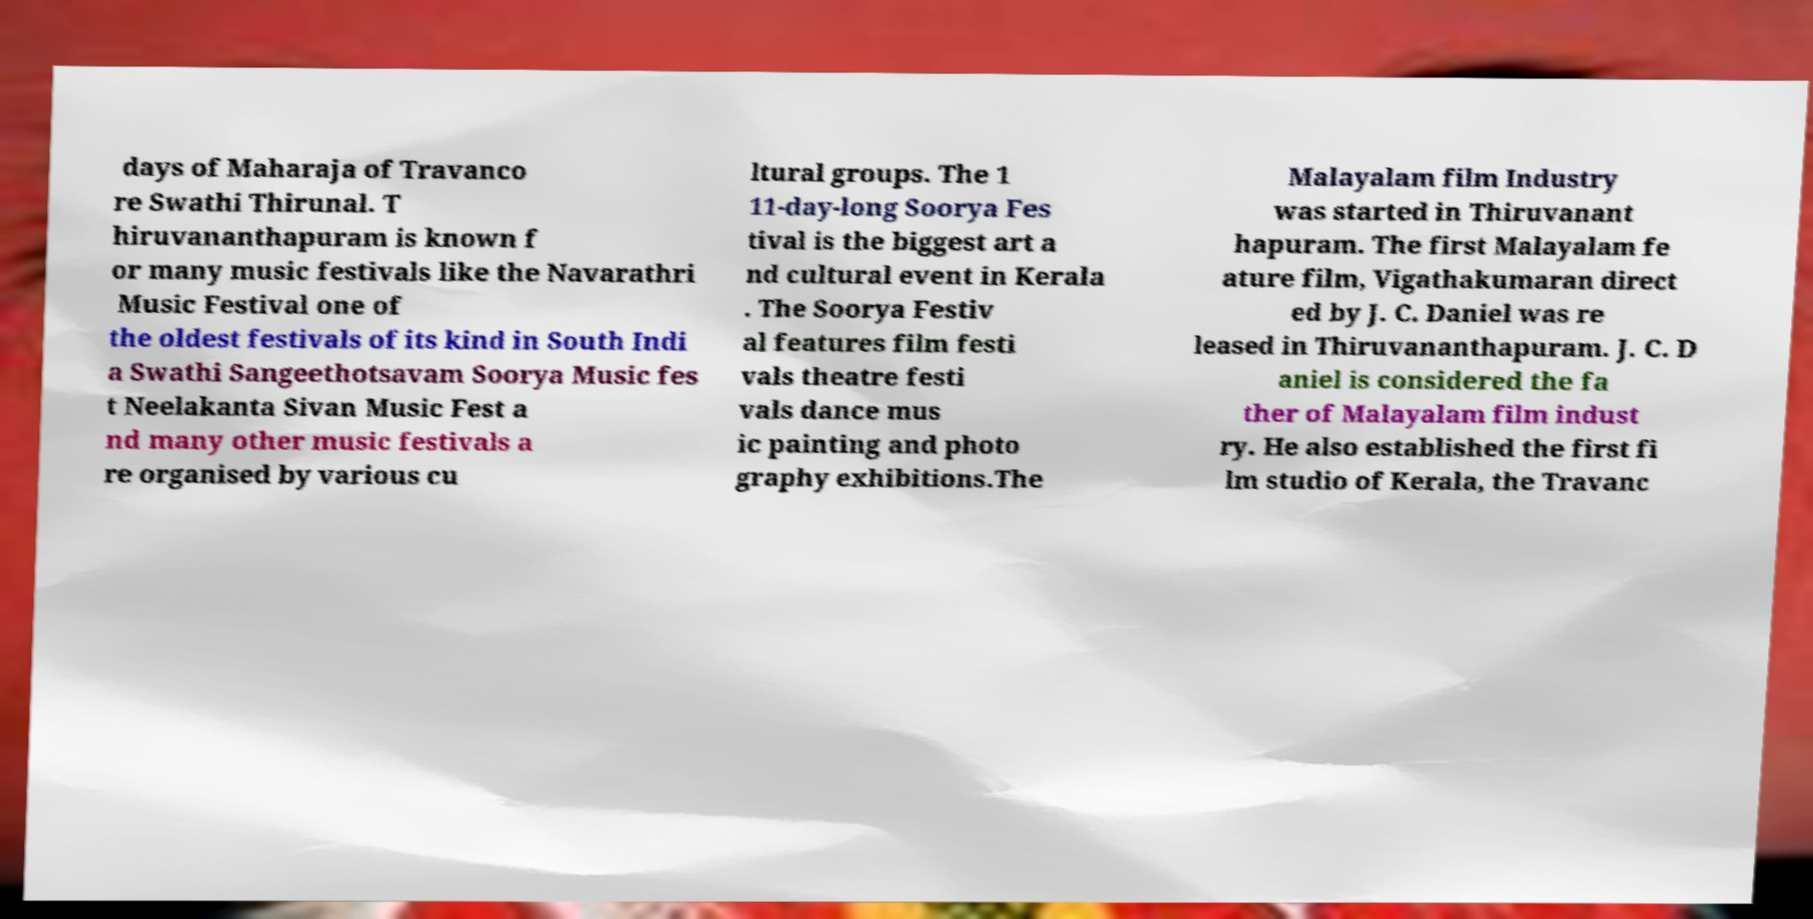Can you read and provide the text displayed in the image?This photo seems to have some interesting text. Can you extract and type it out for me? days of Maharaja of Travanco re Swathi Thirunal. T hiruvananthapuram is known f or many music festivals like the Navarathri Music Festival one of the oldest festivals of its kind in South Indi a Swathi Sangeethotsavam Soorya Music fes t Neelakanta Sivan Music Fest a nd many other music festivals a re organised by various cu ltural groups. The 1 11-day-long Soorya Fes tival is the biggest art a nd cultural event in Kerala . The Soorya Festiv al features film festi vals theatre festi vals dance mus ic painting and photo graphy exhibitions.The Malayalam film Industry was started in Thiruvanant hapuram. The first Malayalam fe ature film, Vigathakumaran direct ed by J. C. Daniel was re leased in Thiruvananthapuram. J. C. D aniel is considered the fa ther of Malayalam film indust ry. He also established the first fi lm studio of Kerala, the Travanc 